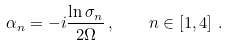<formula> <loc_0><loc_0><loc_500><loc_500>\alpha _ { n } = - i \frac { \ln \sigma _ { n } } { 2 \Omega } \, , \quad n \in \left [ 1 , 4 \right ] \, .</formula> 